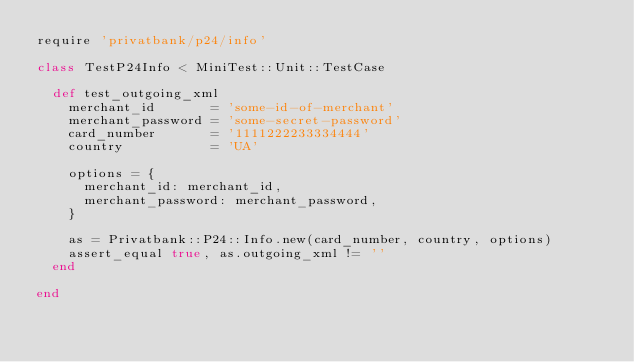<code> <loc_0><loc_0><loc_500><loc_500><_Ruby_>require 'privatbank/p24/info'

class TestP24Info < MiniTest::Unit::TestCase

  def test_outgoing_xml
    merchant_id       = 'some-id-of-merchant'
    merchant_password = 'some-secret-password'
    card_number       = '1111222233334444'
    country           = 'UA'

    options = {
      merchant_id: merchant_id,
      merchant_password: merchant_password,
    }

    as = Privatbank::P24::Info.new(card_number, country, options)
    assert_equal true, as.outgoing_xml != ''
  end

end
</code> 